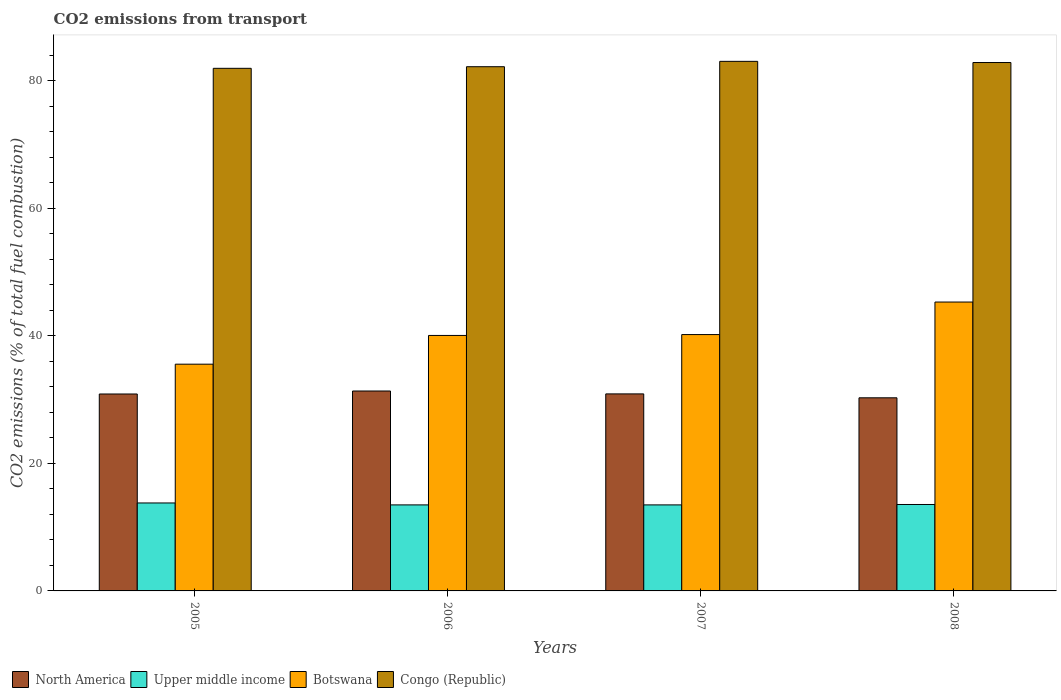How many groups of bars are there?
Ensure brevity in your answer.  4. How many bars are there on the 4th tick from the left?
Provide a succinct answer. 4. What is the total CO2 emitted in North America in 2008?
Your answer should be very brief. 30.27. Across all years, what is the maximum total CO2 emitted in Congo (Republic)?
Your answer should be very brief. 83.02. Across all years, what is the minimum total CO2 emitted in North America?
Give a very brief answer. 30.27. In which year was the total CO2 emitted in Upper middle income maximum?
Provide a short and direct response. 2005. What is the total total CO2 emitted in Upper middle income in the graph?
Ensure brevity in your answer.  54.31. What is the difference between the total CO2 emitted in Upper middle income in 2006 and that in 2008?
Your response must be concise. -0.06. What is the difference between the total CO2 emitted in Botswana in 2008 and the total CO2 emitted in Upper middle income in 2006?
Your answer should be very brief. 31.8. What is the average total CO2 emitted in North America per year?
Ensure brevity in your answer.  30.84. In the year 2007, what is the difference between the total CO2 emitted in North America and total CO2 emitted in Botswana?
Provide a short and direct response. -9.3. What is the ratio of the total CO2 emitted in Upper middle income in 2006 to that in 2008?
Offer a very short reply. 1. Is the difference between the total CO2 emitted in North America in 2006 and 2008 greater than the difference between the total CO2 emitted in Botswana in 2006 and 2008?
Offer a very short reply. Yes. What is the difference between the highest and the second highest total CO2 emitted in Upper middle income?
Your answer should be compact. 0.24. What is the difference between the highest and the lowest total CO2 emitted in Botswana?
Your answer should be compact. 9.74. Is the sum of the total CO2 emitted in Botswana in 2006 and 2007 greater than the maximum total CO2 emitted in Congo (Republic) across all years?
Provide a short and direct response. No. What does the 2nd bar from the left in 2007 represents?
Provide a succinct answer. Upper middle income. Is it the case that in every year, the sum of the total CO2 emitted in Botswana and total CO2 emitted in Upper middle income is greater than the total CO2 emitted in Congo (Republic)?
Offer a terse response. No. How many years are there in the graph?
Provide a succinct answer. 4. What is the difference between two consecutive major ticks on the Y-axis?
Your answer should be very brief. 20. Does the graph contain any zero values?
Offer a terse response. No. Does the graph contain grids?
Your response must be concise. No. Where does the legend appear in the graph?
Provide a short and direct response. Bottom left. What is the title of the graph?
Keep it short and to the point. CO2 emissions from transport. Does "Latin America(all income levels)" appear as one of the legend labels in the graph?
Your response must be concise. No. What is the label or title of the Y-axis?
Offer a terse response. CO2 emissions (% of total fuel combustion). What is the CO2 emissions (% of total fuel combustion) of North America in 2005?
Give a very brief answer. 30.87. What is the CO2 emissions (% of total fuel combustion) of Upper middle income in 2005?
Your response must be concise. 13.79. What is the CO2 emissions (% of total fuel combustion) in Botswana in 2005?
Your response must be concise. 35.55. What is the CO2 emissions (% of total fuel combustion) in Congo (Republic) in 2005?
Your answer should be very brief. 81.93. What is the CO2 emissions (% of total fuel combustion) of North America in 2006?
Offer a very short reply. 31.34. What is the CO2 emissions (% of total fuel combustion) in Upper middle income in 2006?
Your answer should be very brief. 13.49. What is the CO2 emissions (% of total fuel combustion) of Botswana in 2006?
Offer a terse response. 40.05. What is the CO2 emissions (% of total fuel combustion) of Congo (Republic) in 2006?
Offer a terse response. 82.18. What is the CO2 emissions (% of total fuel combustion) in North America in 2007?
Your answer should be very brief. 30.89. What is the CO2 emissions (% of total fuel combustion) in Upper middle income in 2007?
Your answer should be very brief. 13.49. What is the CO2 emissions (% of total fuel combustion) in Botswana in 2007?
Your response must be concise. 40.19. What is the CO2 emissions (% of total fuel combustion) of Congo (Republic) in 2007?
Your answer should be compact. 83.02. What is the CO2 emissions (% of total fuel combustion) of North America in 2008?
Your answer should be very brief. 30.27. What is the CO2 emissions (% of total fuel combustion) in Upper middle income in 2008?
Provide a short and direct response. 13.55. What is the CO2 emissions (% of total fuel combustion) in Botswana in 2008?
Offer a very short reply. 45.29. What is the CO2 emissions (% of total fuel combustion) of Congo (Republic) in 2008?
Provide a succinct answer. 82.84. Across all years, what is the maximum CO2 emissions (% of total fuel combustion) of North America?
Offer a very short reply. 31.34. Across all years, what is the maximum CO2 emissions (% of total fuel combustion) of Upper middle income?
Offer a terse response. 13.79. Across all years, what is the maximum CO2 emissions (% of total fuel combustion) in Botswana?
Ensure brevity in your answer.  45.29. Across all years, what is the maximum CO2 emissions (% of total fuel combustion) of Congo (Republic)?
Provide a short and direct response. 83.02. Across all years, what is the minimum CO2 emissions (% of total fuel combustion) in North America?
Your response must be concise. 30.27. Across all years, what is the minimum CO2 emissions (% of total fuel combustion) of Upper middle income?
Your answer should be very brief. 13.49. Across all years, what is the minimum CO2 emissions (% of total fuel combustion) of Botswana?
Offer a very short reply. 35.55. Across all years, what is the minimum CO2 emissions (% of total fuel combustion) of Congo (Republic)?
Offer a very short reply. 81.93. What is the total CO2 emissions (% of total fuel combustion) of North America in the graph?
Ensure brevity in your answer.  123.37. What is the total CO2 emissions (% of total fuel combustion) of Upper middle income in the graph?
Your response must be concise. 54.31. What is the total CO2 emissions (% of total fuel combustion) of Botswana in the graph?
Give a very brief answer. 161.07. What is the total CO2 emissions (% of total fuel combustion) of Congo (Republic) in the graph?
Your response must be concise. 329.96. What is the difference between the CO2 emissions (% of total fuel combustion) in North America in 2005 and that in 2006?
Offer a very short reply. -0.47. What is the difference between the CO2 emissions (% of total fuel combustion) of Upper middle income in 2005 and that in 2006?
Your answer should be compact. 0.3. What is the difference between the CO2 emissions (% of total fuel combustion) in Botswana in 2005 and that in 2006?
Your answer should be compact. -4.5. What is the difference between the CO2 emissions (% of total fuel combustion) in Congo (Republic) in 2005 and that in 2006?
Provide a short and direct response. -0.25. What is the difference between the CO2 emissions (% of total fuel combustion) in North America in 2005 and that in 2007?
Keep it short and to the point. -0.02. What is the difference between the CO2 emissions (% of total fuel combustion) of Upper middle income in 2005 and that in 2007?
Make the answer very short. 0.3. What is the difference between the CO2 emissions (% of total fuel combustion) of Botswana in 2005 and that in 2007?
Your response must be concise. -4.64. What is the difference between the CO2 emissions (% of total fuel combustion) in Congo (Republic) in 2005 and that in 2007?
Give a very brief answer. -1.09. What is the difference between the CO2 emissions (% of total fuel combustion) in North America in 2005 and that in 2008?
Make the answer very short. 0.6. What is the difference between the CO2 emissions (% of total fuel combustion) of Upper middle income in 2005 and that in 2008?
Provide a succinct answer. 0.24. What is the difference between the CO2 emissions (% of total fuel combustion) in Botswana in 2005 and that in 2008?
Offer a very short reply. -9.74. What is the difference between the CO2 emissions (% of total fuel combustion) of Congo (Republic) in 2005 and that in 2008?
Offer a very short reply. -0.91. What is the difference between the CO2 emissions (% of total fuel combustion) of North America in 2006 and that in 2007?
Provide a short and direct response. 0.45. What is the difference between the CO2 emissions (% of total fuel combustion) in Botswana in 2006 and that in 2007?
Your answer should be very brief. -0.14. What is the difference between the CO2 emissions (% of total fuel combustion) of Congo (Republic) in 2006 and that in 2007?
Make the answer very short. -0.84. What is the difference between the CO2 emissions (% of total fuel combustion) in North America in 2006 and that in 2008?
Offer a terse response. 1.07. What is the difference between the CO2 emissions (% of total fuel combustion) in Upper middle income in 2006 and that in 2008?
Make the answer very short. -0.06. What is the difference between the CO2 emissions (% of total fuel combustion) of Botswana in 2006 and that in 2008?
Make the answer very short. -5.24. What is the difference between the CO2 emissions (% of total fuel combustion) of Congo (Republic) in 2006 and that in 2008?
Offer a terse response. -0.66. What is the difference between the CO2 emissions (% of total fuel combustion) of North America in 2007 and that in 2008?
Your answer should be very brief. 0.61. What is the difference between the CO2 emissions (% of total fuel combustion) of Upper middle income in 2007 and that in 2008?
Keep it short and to the point. -0.06. What is the difference between the CO2 emissions (% of total fuel combustion) in Botswana in 2007 and that in 2008?
Make the answer very short. -5.1. What is the difference between the CO2 emissions (% of total fuel combustion) of Congo (Republic) in 2007 and that in 2008?
Make the answer very short. 0.18. What is the difference between the CO2 emissions (% of total fuel combustion) in North America in 2005 and the CO2 emissions (% of total fuel combustion) in Upper middle income in 2006?
Make the answer very short. 17.39. What is the difference between the CO2 emissions (% of total fuel combustion) in North America in 2005 and the CO2 emissions (% of total fuel combustion) in Botswana in 2006?
Your answer should be compact. -9.18. What is the difference between the CO2 emissions (% of total fuel combustion) of North America in 2005 and the CO2 emissions (% of total fuel combustion) of Congo (Republic) in 2006?
Your answer should be very brief. -51.31. What is the difference between the CO2 emissions (% of total fuel combustion) in Upper middle income in 2005 and the CO2 emissions (% of total fuel combustion) in Botswana in 2006?
Give a very brief answer. -26.26. What is the difference between the CO2 emissions (% of total fuel combustion) in Upper middle income in 2005 and the CO2 emissions (% of total fuel combustion) in Congo (Republic) in 2006?
Ensure brevity in your answer.  -68.39. What is the difference between the CO2 emissions (% of total fuel combustion) in Botswana in 2005 and the CO2 emissions (% of total fuel combustion) in Congo (Republic) in 2006?
Your answer should be compact. -46.63. What is the difference between the CO2 emissions (% of total fuel combustion) in North America in 2005 and the CO2 emissions (% of total fuel combustion) in Upper middle income in 2007?
Your answer should be compact. 17.39. What is the difference between the CO2 emissions (% of total fuel combustion) of North America in 2005 and the CO2 emissions (% of total fuel combustion) of Botswana in 2007?
Offer a very short reply. -9.32. What is the difference between the CO2 emissions (% of total fuel combustion) of North America in 2005 and the CO2 emissions (% of total fuel combustion) of Congo (Republic) in 2007?
Offer a terse response. -52.15. What is the difference between the CO2 emissions (% of total fuel combustion) of Upper middle income in 2005 and the CO2 emissions (% of total fuel combustion) of Botswana in 2007?
Your response must be concise. -26.4. What is the difference between the CO2 emissions (% of total fuel combustion) of Upper middle income in 2005 and the CO2 emissions (% of total fuel combustion) of Congo (Republic) in 2007?
Your answer should be compact. -69.23. What is the difference between the CO2 emissions (% of total fuel combustion) in Botswana in 2005 and the CO2 emissions (% of total fuel combustion) in Congo (Republic) in 2007?
Your answer should be compact. -47.47. What is the difference between the CO2 emissions (% of total fuel combustion) of North America in 2005 and the CO2 emissions (% of total fuel combustion) of Upper middle income in 2008?
Offer a terse response. 17.32. What is the difference between the CO2 emissions (% of total fuel combustion) of North America in 2005 and the CO2 emissions (% of total fuel combustion) of Botswana in 2008?
Provide a succinct answer. -14.42. What is the difference between the CO2 emissions (% of total fuel combustion) in North America in 2005 and the CO2 emissions (% of total fuel combustion) in Congo (Republic) in 2008?
Keep it short and to the point. -51.96. What is the difference between the CO2 emissions (% of total fuel combustion) of Upper middle income in 2005 and the CO2 emissions (% of total fuel combustion) of Botswana in 2008?
Your response must be concise. -31.5. What is the difference between the CO2 emissions (% of total fuel combustion) in Upper middle income in 2005 and the CO2 emissions (% of total fuel combustion) in Congo (Republic) in 2008?
Your answer should be very brief. -69.05. What is the difference between the CO2 emissions (% of total fuel combustion) of Botswana in 2005 and the CO2 emissions (% of total fuel combustion) of Congo (Republic) in 2008?
Give a very brief answer. -47.29. What is the difference between the CO2 emissions (% of total fuel combustion) of North America in 2006 and the CO2 emissions (% of total fuel combustion) of Upper middle income in 2007?
Give a very brief answer. 17.85. What is the difference between the CO2 emissions (% of total fuel combustion) of North America in 2006 and the CO2 emissions (% of total fuel combustion) of Botswana in 2007?
Offer a very short reply. -8.85. What is the difference between the CO2 emissions (% of total fuel combustion) of North America in 2006 and the CO2 emissions (% of total fuel combustion) of Congo (Republic) in 2007?
Make the answer very short. -51.68. What is the difference between the CO2 emissions (% of total fuel combustion) of Upper middle income in 2006 and the CO2 emissions (% of total fuel combustion) of Botswana in 2007?
Ensure brevity in your answer.  -26.7. What is the difference between the CO2 emissions (% of total fuel combustion) of Upper middle income in 2006 and the CO2 emissions (% of total fuel combustion) of Congo (Republic) in 2007?
Offer a very short reply. -69.53. What is the difference between the CO2 emissions (% of total fuel combustion) of Botswana in 2006 and the CO2 emissions (% of total fuel combustion) of Congo (Republic) in 2007?
Make the answer very short. -42.97. What is the difference between the CO2 emissions (% of total fuel combustion) in North America in 2006 and the CO2 emissions (% of total fuel combustion) in Upper middle income in 2008?
Offer a very short reply. 17.79. What is the difference between the CO2 emissions (% of total fuel combustion) of North America in 2006 and the CO2 emissions (% of total fuel combustion) of Botswana in 2008?
Give a very brief answer. -13.95. What is the difference between the CO2 emissions (% of total fuel combustion) of North America in 2006 and the CO2 emissions (% of total fuel combustion) of Congo (Republic) in 2008?
Give a very brief answer. -51.5. What is the difference between the CO2 emissions (% of total fuel combustion) in Upper middle income in 2006 and the CO2 emissions (% of total fuel combustion) in Botswana in 2008?
Make the answer very short. -31.8. What is the difference between the CO2 emissions (% of total fuel combustion) in Upper middle income in 2006 and the CO2 emissions (% of total fuel combustion) in Congo (Republic) in 2008?
Provide a succinct answer. -69.35. What is the difference between the CO2 emissions (% of total fuel combustion) in Botswana in 2006 and the CO2 emissions (% of total fuel combustion) in Congo (Republic) in 2008?
Give a very brief answer. -42.79. What is the difference between the CO2 emissions (% of total fuel combustion) of North America in 2007 and the CO2 emissions (% of total fuel combustion) of Upper middle income in 2008?
Provide a succinct answer. 17.34. What is the difference between the CO2 emissions (% of total fuel combustion) in North America in 2007 and the CO2 emissions (% of total fuel combustion) in Botswana in 2008?
Offer a very short reply. -14.4. What is the difference between the CO2 emissions (% of total fuel combustion) in North America in 2007 and the CO2 emissions (% of total fuel combustion) in Congo (Republic) in 2008?
Keep it short and to the point. -51.95. What is the difference between the CO2 emissions (% of total fuel combustion) in Upper middle income in 2007 and the CO2 emissions (% of total fuel combustion) in Botswana in 2008?
Provide a short and direct response. -31.8. What is the difference between the CO2 emissions (% of total fuel combustion) of Upper middle income in 2007 and the CO2 emissions (% of total fuel combustion) of Congo (Republic) in 2008?
Your response must be concise. -69.35. What is the difference between the CO2 emissions (% of total fuel combustion) of Botswana in 2007 and the CO2 emissions (% of total fuel combustion) of Congo (Republic) in 2008?
Make the answer very short. -42.65. What is the average CO2 emissions (% of total fuel combustion) of North America per year?
Give a very brief answer. 30.84. What is the average CO2 emissions (% of total fuel combustion) in Upper middle income per year?
Offer a very short reply. 13.58. What is the average CO2 emissions (% of total fuel combustion) of Botswana per year?
Provide a succinct answer. 40.27. What is the average CO2 emissions (% of total fuel combustion) of Congo (Republic) per year?
Keep it short and to the point. 82.49. In the year 2005, what is the difference between the CO2 emissions (% of total fuel combustion) of North America and CO2 emissions (% of total fuel combustion) of Upper middle income?
Provide a short and direct response. 17.08. In the year 2005, what is the difference between the CO2 emissions (% of total fuel combustion) in North America and CO2 emissions (% of total fuel combustion) in Botswana?
Your answer should be very brief. -4.67. In the year 2005, what is the difference between the CO2 emissions (% of total fuel combustion) in North America and CO2 emissions (% of total fuel combustion) in Congo (Republic)?
Make the answer very short. -51.06. In the year 2005, what is the difference between the CO2 emissions (% of total fuel combustion) of Upper middle income and CO2 emissions (% of total fuel combustion) of Botswana?
Provide a succinct answer. -21.76. In the year 2005, what is the difference between the CO2 emissions (% of total fuel combustion) of Upper middle income and CO2 emissions (% of total fuel combustion) of Congo (Republic)?
Your response must be concise. -68.14. In the year 2005, what is the difference between the CO2 emissions (% of total fuel combustion) of Botswana and CO2 emissions (% of total fuel combustion) of Congo (Republic)?
Make the answer very short. -46.38. In the year 2006, what is the difference between the CO2 emissions (% of total fuel combustion) of North America and CO2 emissions (% of total fuel combustion) of Upper middle income?
Your answer should be very brief. 17.85. In the year 2006, what is the difference between the CO2 emissions (% of total fuel combustion) of North America and CO2 emissions (% of total fuel combustion) of Botswana?
Provide a short and direct response. -8.71. In the year 2006, what is the difference between the CO2 emissions (% of total fuel combustion) of North America and CO2 emissions (% of total fuel combustion) of Congo (Republic)?
Offer a very short reply. -50.84. In the year 2006, what is the difference between the CO2 emissions (% of total fuel combustion) of Upper middle income and CO2 emissions (% of total fuel combustion) of Botswana?
Provide a short and direct response. -26.56. In the year 2006, what is the difference between the CO2 emissions (% of total fuel combustion) of Upper middle income and CO2 emissions (% of total fuel combustion) of Congo (Republic)?
Provide a succinct answer. -68.69. In the year 2006, what is the difference between the CO2 emissions (% of total fuel combustion) in Botswana and CO2 emissions (% of total fuel combustion) in Congo (Republic)?
Give a very brief answer. -42.13. In the year 2007, what is the difference between the CO2 emissions (% of total fuel combustion) in North America and CO2 emissions (% of total fuel combustion) in Upper middle income?
Ensure brevity in your answer.  17.4. In the year 2007, what is the difference between the CO2 emissions (% of total fuel combustion) of North America and CO2 emissions (% of total fuel combustion) of Botswana?
Keep it short and to the point. -9.3. In the year 2007, what is the difference between the CO2 emissions (% of total fuel combustion) of North America and CO2 emissions (% of total fuel combustion) of Congo (Republic)?
Your answer should be very brief. -52.13. In the year 2007, what is the difference between the CO2 emissions (% of total fuel combustion) of Upper middle income and CO2 emissions (% of total fuel combustion) of Botswana?
Ensure brevity in your answer.  -26.7. In the year 2007, what is the difference between the CO2 emissions (% of total fuel combustion) of Upper middle income and CO2 emissions (% of total fuel combustion) of Congo (Republic)?
Give a very brief answer. -69.53. In the year 2007, what is the difference between the CO2 emissions (% of total fuel combustion) in Botswana and CO2 emissions (% of total fuel combustion) in Congo (Republic)?
Offer a very short reply. -42.83. In the year 2008, what is the difference between the CO2 emissions (% of total fuel combustion) of North America and CO2 emissions (% of total fuel combustion) of Upper middle income?
Make the answer very short. 16.73. In the year 2008, what is the difference between the CO2 emissions (% of total fuel combustion) in North America and CO2 emissions (% of total fuel combustion) in Botswana?
Your response must be concise. -15.01. In the year 2008, what is the difference between the CO2 emissions (% of total fuel combustion) in North America and CO2 emissions (% of total fuel combustion) in Congo (Republic)?
Offer a terse response. -52.56. In the year 2008, what is the difference between the CO2 emissions (% of total fuel combustion) in Upper middle income and CO2 emissions (% of total fuel combustion) in Botswana?
Your answer should be compact. -31.74. In the year 2008, what is the difference between the CO2 emissions (% of total fuel combustion) of Upper middle income and CO2 emissions (% of total fuel combustion) of Congo (Republic)?
Offer a very short reply. -69.29. In the year 2008, what is the difference between the CO2 emissions (% of total fuel combustion) of Botswana and CO2 emissions (% of total fuel combustion) of Congo (Republic)?
Your answer should be compact. -37.55. What is the ratio of the CO2 emissions (% of total fuel combustion) in North America in 2005 to that in 2006?
Make the answer very short. 0.99. What is the ratio of the CO2 emissions (% of total fuel combustion) of Upper middle income in 2005 to that in 2006?
Ensure brevity in your answer.  1.02. What is the ratio of the CO2 emissions (% of total fuel combustion) of Botswana in 2005 to that in 2006?
Provide a short and direct response. 0.89. What is the ratio of the CO2 emissions (% of total fuel combustion) of North America in 2005 to that in 2007?
Your answer should be compact. 1. What is the ratio of the CO2 emissions (% of total fuel combustion) in Upper middle income in 2005 to that in 2007?
Offer a terse response. 1.02. What is the ratio of the CO2 emissions (% of total fuel combustion) in Botswana in 2005 to that in 2007?
Ensure brevity in your answer.  0.88. What is the ratio of the CO2 emissions (% of total fuel combustion) in Congo (Republic) in 2005 to that in 2007?
Your answer should be compact. 0.99. What is the ratio of the CO2 emissions (% of total fuel combustion) in North America in 2005 to that in 2008?
Keep it short and to the point. 1.02. What is the ratio of the CO2 emissions (% of total fuel combustion) of Upper middle income in 2005 to that in 2008?
Provide a short and direct response. 1.02. What is the ratio of the CO2 emissions (% of total fuel combustion) of Botswana in 2005 to that in 2008?
Your response must be concise. 0.78. What is the ratio of the CO2 emissions (% of total fuel combustion) of Congo (Republic) in 2005 to that in 2008?
Make the answer very short. 0.99. What is the ratio of the CO2 emissions (% of total fuel combustion) in North America in 2006 to that in 2007?
Provide a succinct answer. 1.01. What is the ratio of the CO2 emissions (% of total fuel combustion) of North America in 2006 to that in 2008?
Your response must be concise. 1.04. What is the ratio of the CO2 emissions (% of total fuel combustion) of Upper middle income in 2006 to that in 2008?
Keep it short and to the point. 1. What is the ratio of the CO2 emissions (% of total fuel combustion) of Botswana in 2006 to that in 2008?
Give a very brief answer. 0.88. What is the ratio of the CO2 emissions (% of total fuel combustion) of North America in 2007 to that in 2008?
Make the answer very short. 1.02. What is the ratio of the CO2 emissions (% of total fuel combustion) of Upper middle income in 2007 to that in 2008?
Offer a very short reply. 1. What is the ratio of the CO2 emissions (% of total fuel combustion) of Botswana in 2007 to that in 2008?
Provide a succinct answer. 0.89. What is the difference between the highest and the second highest CO2 emissions (% of total fuel combustion) of North America?
Your response must be concise. 0.45. What is the difference between the highest and the second highest CO2 emissions (% of total fuel combustion) in Upper middle income?
Provide a short and direct response. 0.24. What is the difference between the highest and the second highest CO2 emissions (% of total fuel combustion) in Botswana?
Provide a short and direct response. 5.1. What is the difference between the highest and the second highest CO2 emissions (% of total fuel combustion) in Congo (Republic)?
Provide a short and direct response. 0.18. What is the difference between the highest and the lowest CO2 emissions (% of total fuel combustion) in North America?
Your answer should be very brief. 1.07. What is the difference between the highest and the lowest CO2 emissions (% of total fuel combustion) of Upper middle income?
Your answer should be very brief. 0.3. What is the difference between the highest and the lowest CO2 emissions (% of total fuel combustion) in Botswana?
Your answer should be compact. 9.74. What is the difference between the highest and the lowest CO2 emissions (% of total fuel combustion) of Congo (Republic)?
Provide a short and direct response. 1.09. 